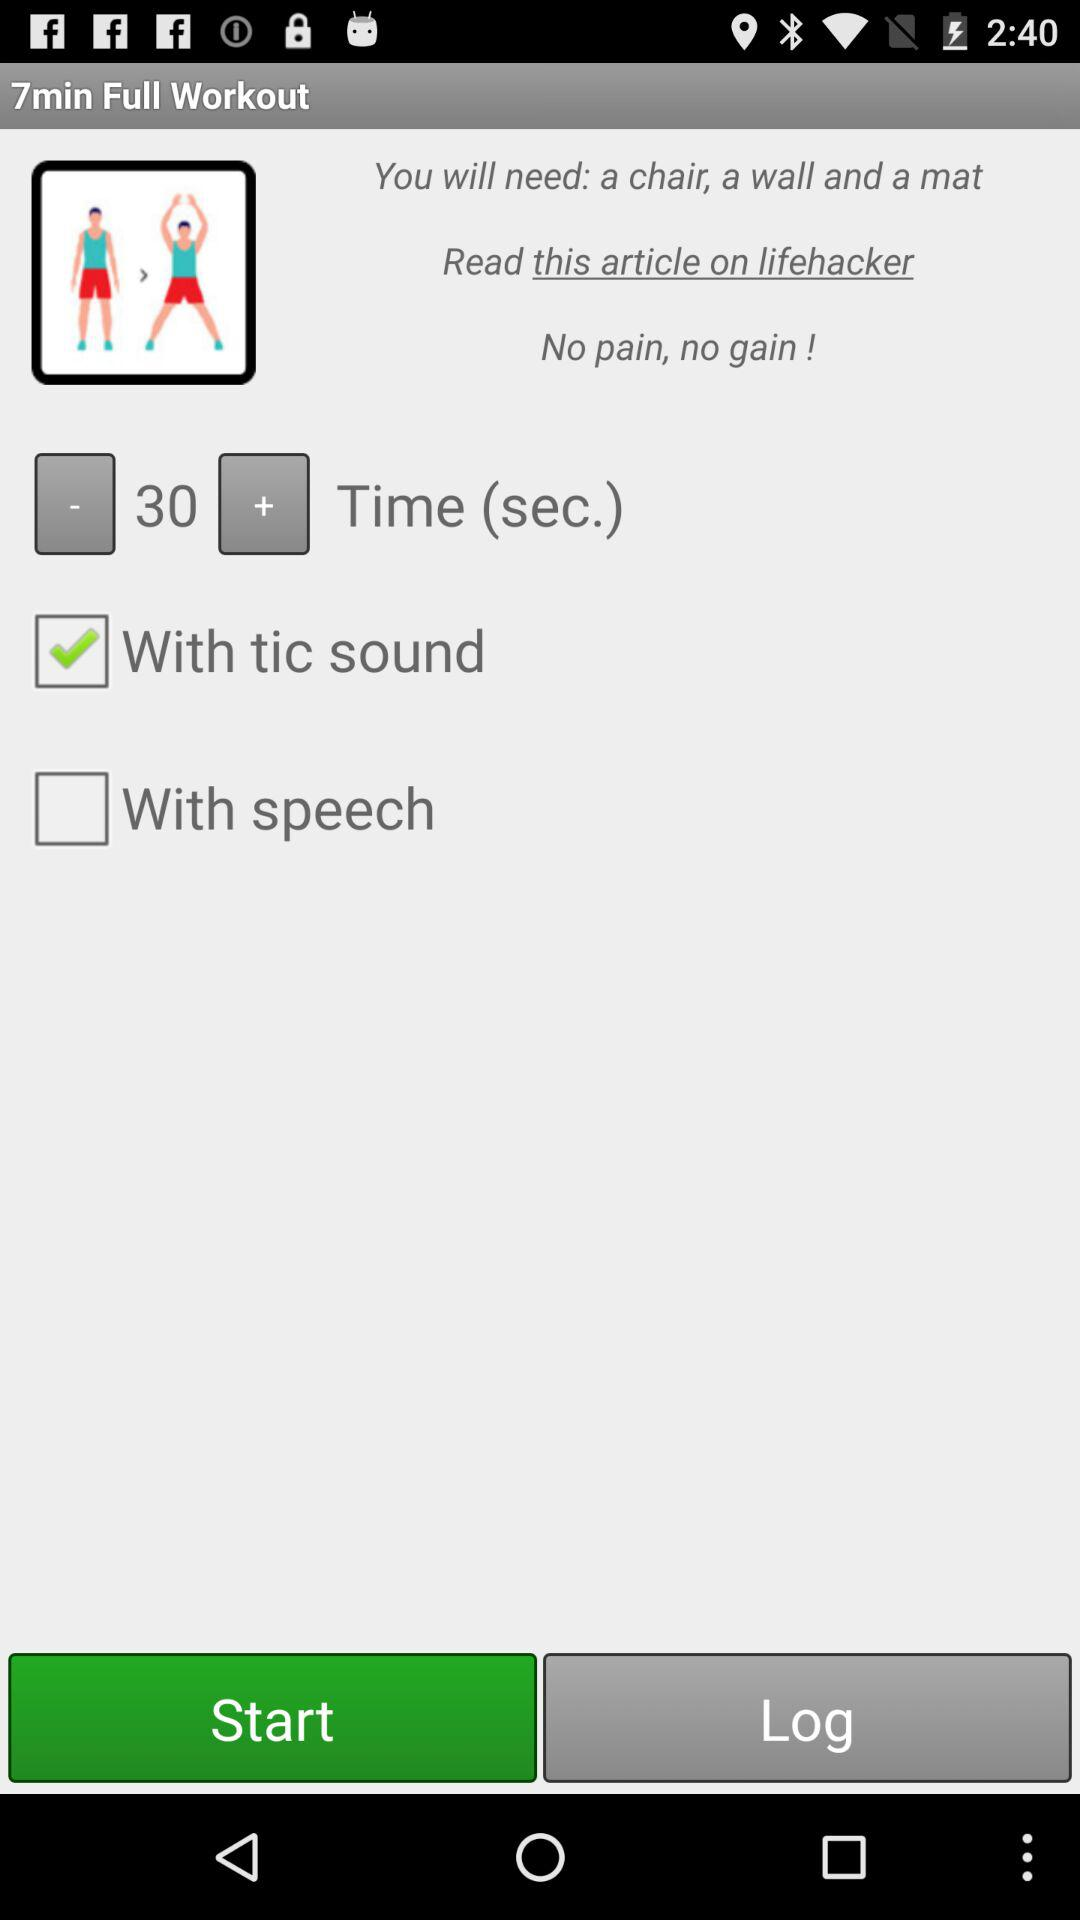Which option is marked as checked? The option that is marked as checked is "With tic sound". 